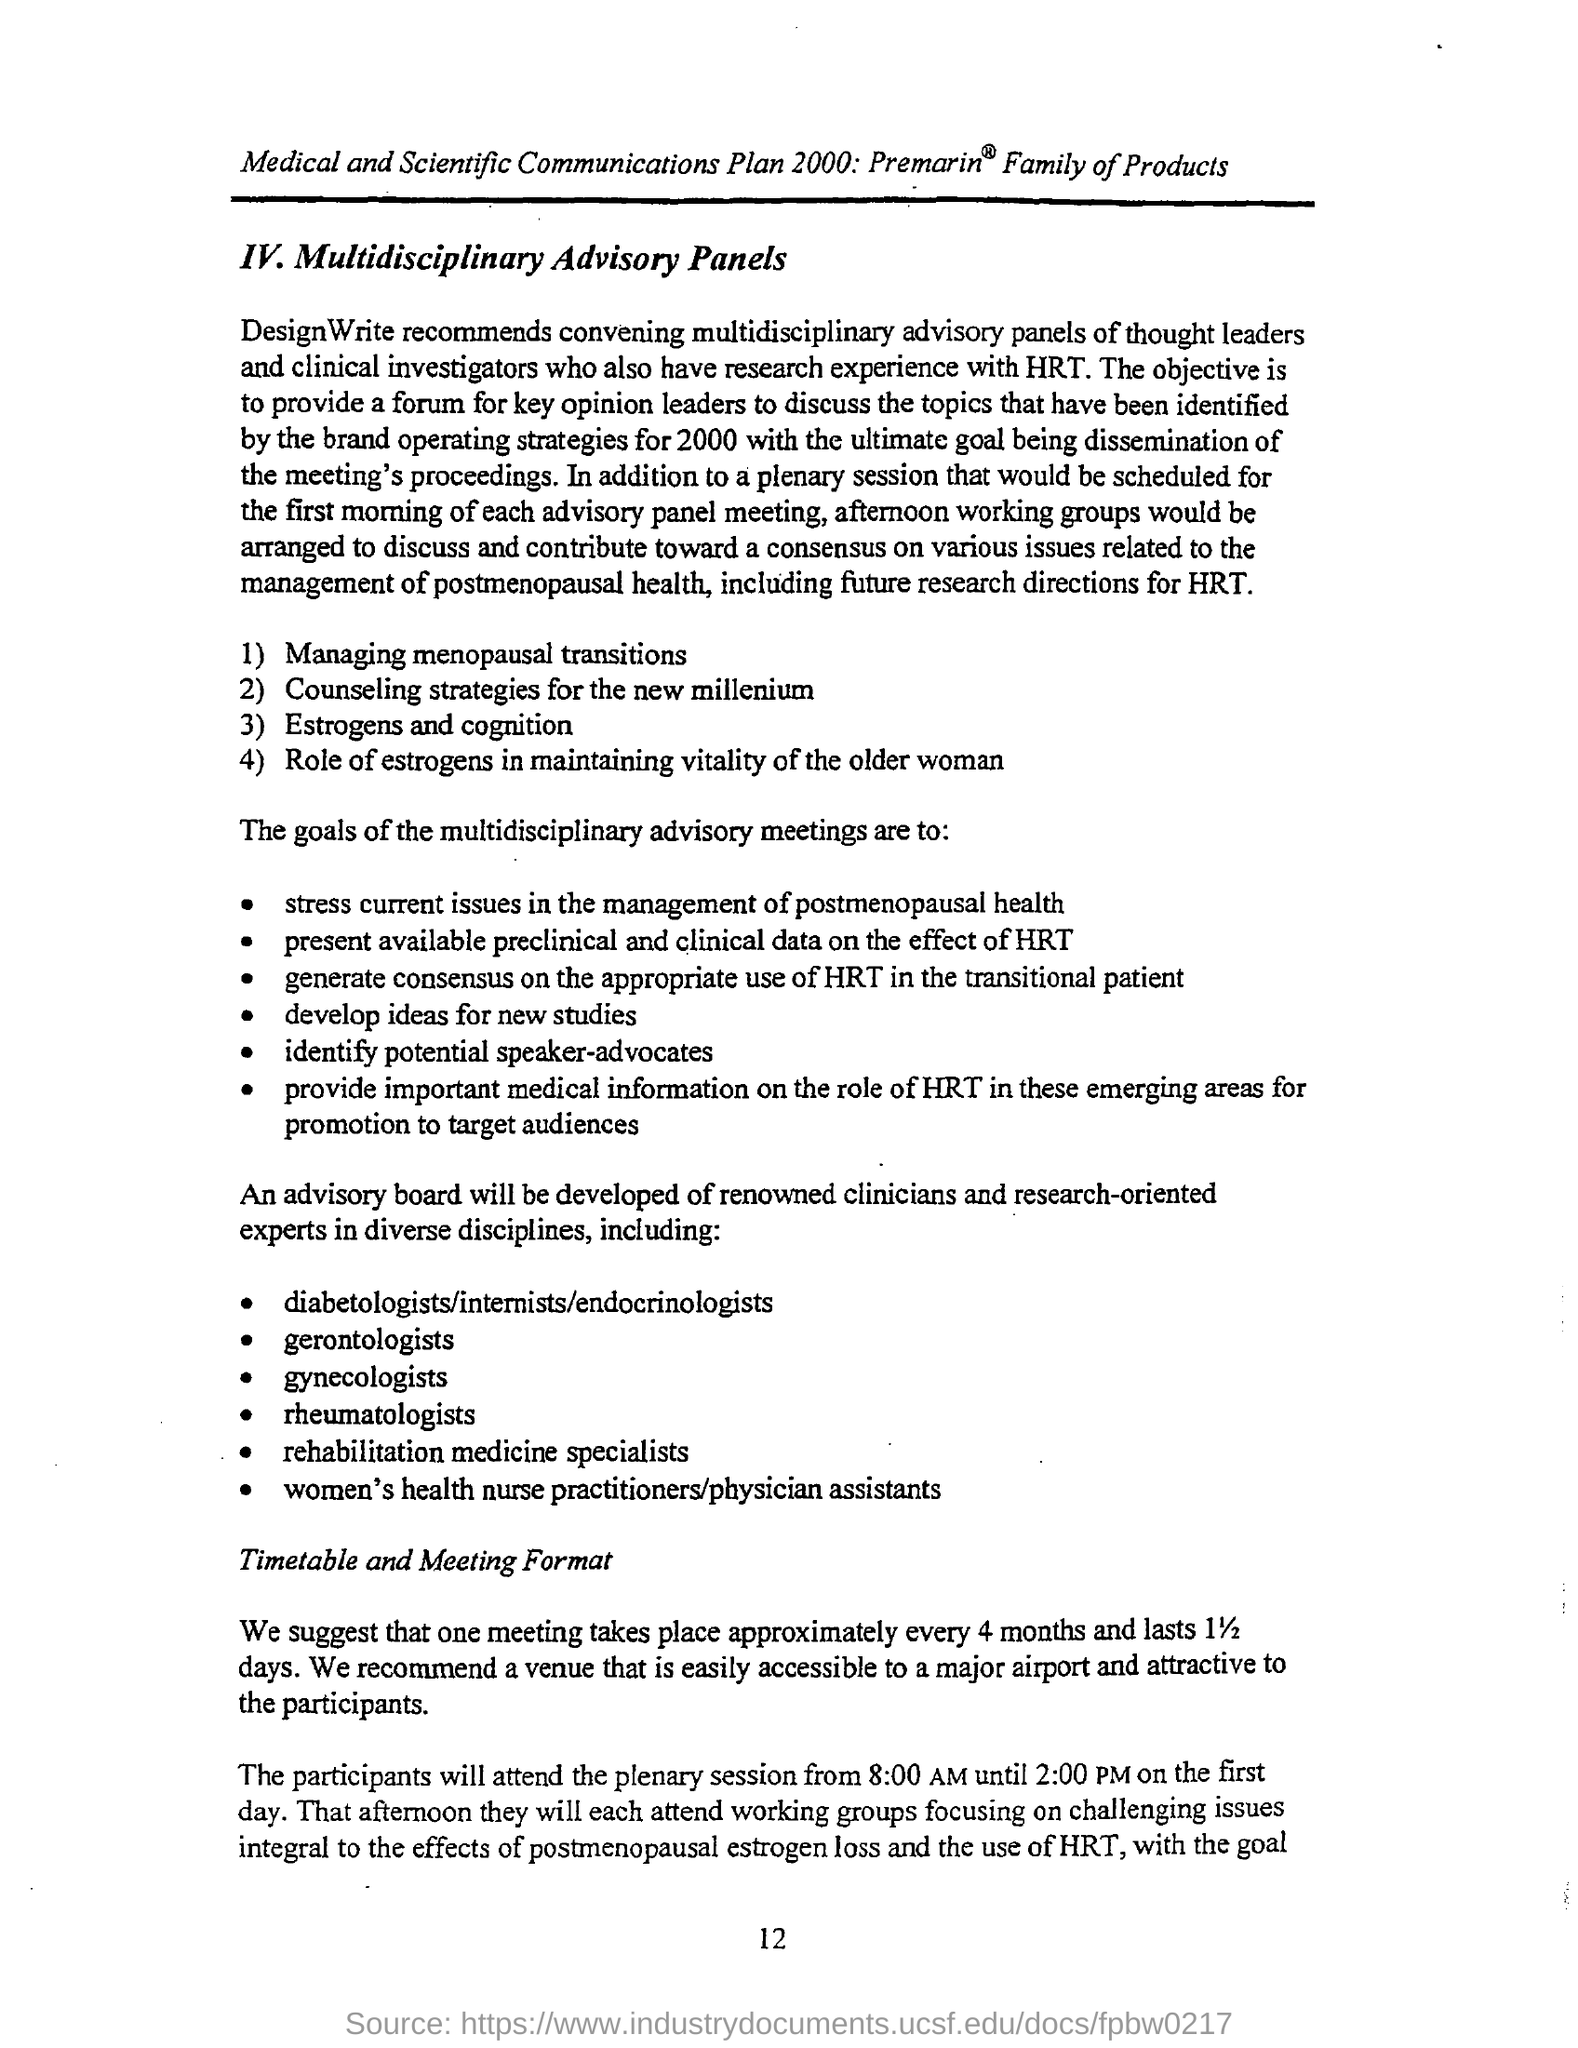What is the page number on this document?
Your response must be concise. 12. When should meeting take place?
Offer a terse response. Every 4 months. 